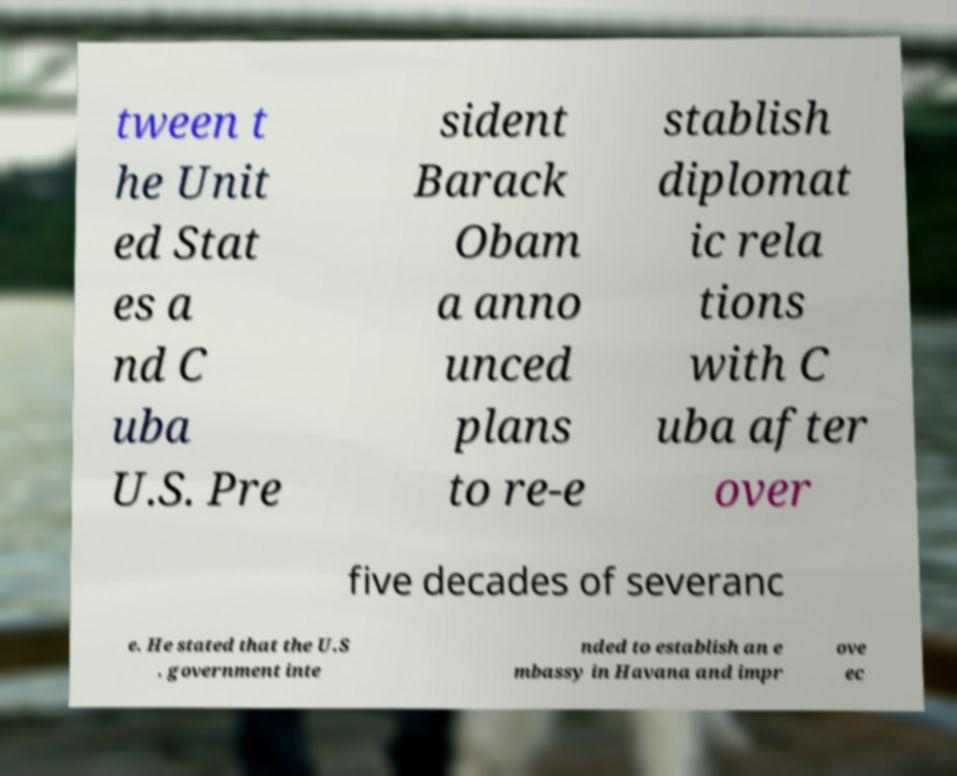I need the written content from this picture converted into text. Can you do that? tween t he Unit ed Stat es a nd C uba U.S. Pre sident Barack Obam a anno unced plans to re-e stablish diplomat ic rela tions with C uba after over five decades of severanc e. He stated that the U.S . government inte nded to establish an e mbassy in Havana and impr ove ec 